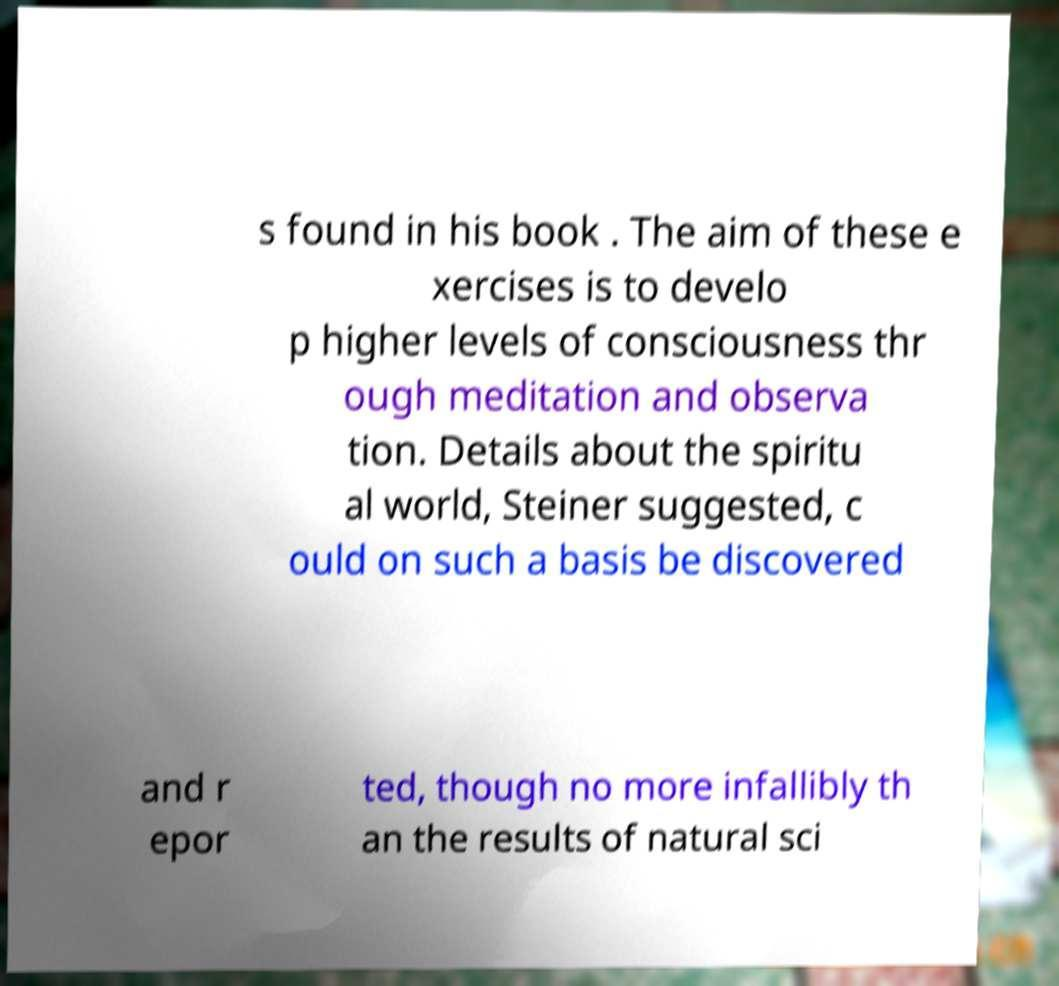Please read and relay the text visible in this image. What does it say? s found in his book . The aim of these e xercises is to develo p higher levels of consciousness thr ough meditation and observa tion. Details about the spiritu al world, Steiner suggested, c ould on such a basis be discovered and r epor ted, though no more infallibly th an the results of natural sci 